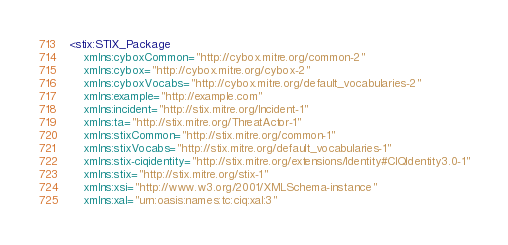<code> <loc_0><loc_0><loc_500><loc_500><_XML_><stix:STIX_Package 
	xmlns:cyboxCommon="http://cybox.mitre.org/common-2"
	xmlns:cybox="http://cybox.mitre.org/cybox-2"
	xmlns:cyboxVocabs="http://cybox.mitre.org/default_vocabularies-2"
	xmlns:example="http://example.com"
	xmlns:incident="http://stix.mitre.org/Incident-1"
	xmlns:ta="http://stix.mitre.org/ThreatActor-1"
	xmlns:stixCommon="http://stix.mitre.org/common-1"
	xmlns:stixVocabs="http://stix.mitre.org/default_vocabularies-1"
	xmlns:stix-ciqidentity="http://stix.mitre.org/extensions/Identity#CIQIdentity3.0-1"
	xmlns:stix="http://stix.mitre.org/stix-1"
	xmlns:xsi="http://www.w3.org/2001/XMLSchema-instance"
	xmlns:xal="urn:oasis:names:tc:ciq:xal:3"</code> 